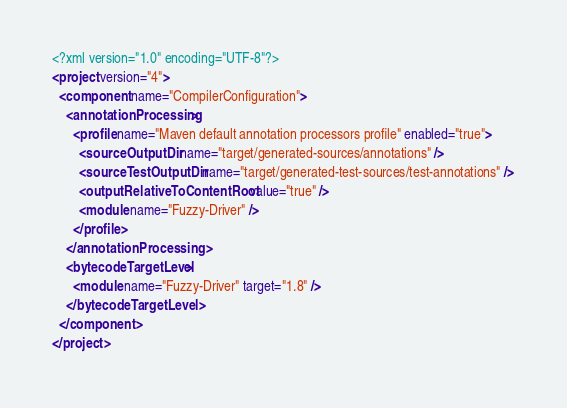<code> <loc_0><loc_0><loc_500><loc_500><_XML_><?xml version="1.0" encoding="UTF-8"?>
<project version="4">
  <component name="CompilerConfiguration">
    <annotationProcessing>
      <profile name="Maven default annotation processors profile" enabled="true">
        <sourceOutputDir name="target/generated-sources/annotations" />
        <sourceTestOutputDir name="target/generated-test-sources/test-annotations" />
        <outputRelativeToContentRoot value="true" />
        <module name="Fuzzy-Driver" />
      </profile>
    </annotationProcessing>
    <bytecodeTargetLevel>
      <module name="Fuzzy-Driver" target="1.8" />
    </bytecodeTargetLevel>
  </component>
</project></code> 